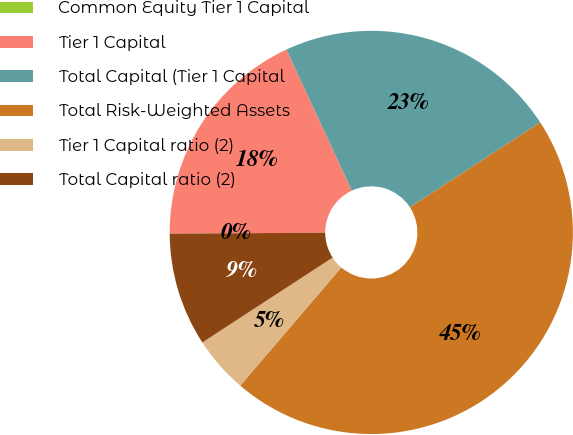Convert chart. <chart><loc_0><loc_0><loc_500><loc_500><pie_chart><fcel>Common Equity Tier 1 Capital<fcel>Tier 1 Capital<fcel>Total Capital (Tier 1 Capital<fcel>Total Risk-Weighted Assets<fcel>Tier 1 Capital ratio (2)<fcel>Total Capital ratio (2)<nl><fcel>0.0%<fcel>18.18%<fcel>22.73%<fcel>45.45%<fcel>4.55%<fcel>9.09%<nl></chart> 